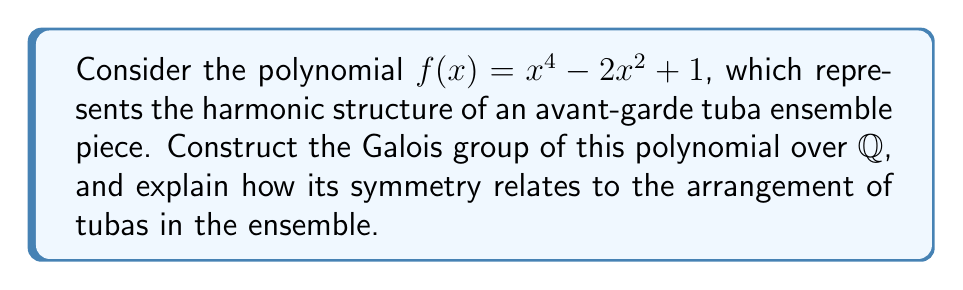Show me your answer to this math problem. 1) First, let's factor the polynomial:
   $f(x) = x^4 - 2x^2 + 1 = (x^2 - 1)^2 = (x-1)^2(x+1)^2$

2) The roots of $f(x)$ are $\{1, -1, 1, -1\}$. Let's call the splitting field $K$.

3) Since all roots are in $\mathbb{Q}$, $K = \mathbb{Q}$. The degree of the extension $[K:\mathbb{Q}] = 1$.

4) The Galois group $Gal(K/\mathbb{Q})$ is isomorphic to the trivial group $\{e\}$, where $e$ is the identity permutation.

5) In terms of tuba ensemble arrangement:
   - The two distinct roots (1 and -1) represent two groups of tubas.
   - The multiplicity of 2 for each root suggests each group contains two tubas.
   - The trivial Galois group implies no permutations between these groups are possible without changing the overall harmonic structure.

6) This symmetry in the polynomial mirrors a rigid arrangement in the avant-garde tuba ensemble, where two pairs of tubas play fixed roles that cannot be interchanged without altering the piece's fundamental structure.
Answer: $Gal(K/\mathbb{Q}) \cong \{e\}$ 